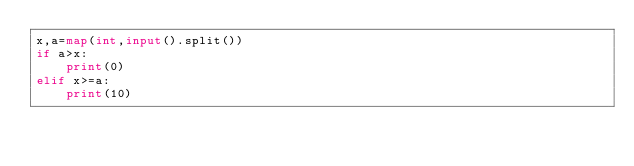<code> <loc_0><loc_0><loc_500><loc_500><_Python_>x,a=map(int,input().split())
if a>x:
    print(0)
elif x>=a:
    print(10)</code> 